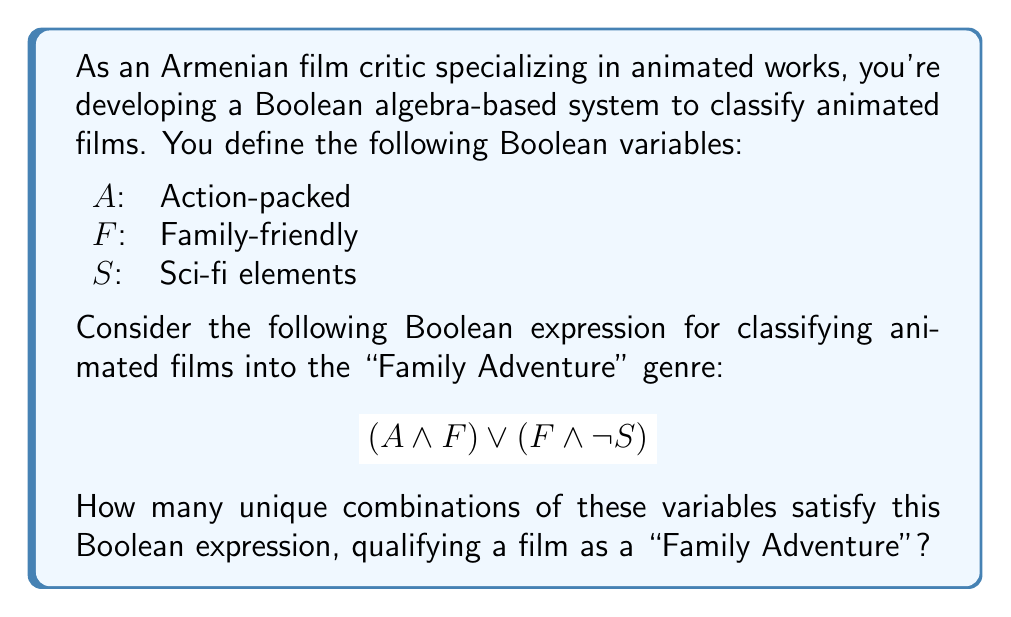Can you answer this question? Let's approach this step-by-step using a truth table:

1) First, we list all possible combinations of $A$, $F$, and $S$:

   $A$ | $F$ | $S$ | $(A \land F)$ | $(F \land \neg S)$ | Result
   ----+-----+-----+---------------+--------------------+-------
   0   | 0   | 0   |      0        |         0          |   0
   0   | 0   | 1   |      0        |         0          |   0
   0   | 1   | 0   |      0        |         1          |   1
   0   | 1   | 1   |      0        |         0          |   0
   1   | 0   | 0   |      0        |         0          |   0
   1   | 0   | 1   |      0        |         0          |   0
   1   | 1   | 0   |      1        |         1          |   1
   1   | 1   | 1   |      1        |         0          |   1

2) We evaluate $(A \land F)$ and $(F \land \neg S)$ for each combination.

3) The final result is the OR (∨) of these two expressions.

4) Counting the number of 1's in the Result column gives us the number of combinations that satisfy the expression.

We can see that there are three combinations that result in a 1:
- $A = 0$, $F = 1$, $S = 0$
- $A = 1$, $F = 1$, $S = 0$
- $A = 1$, $F = 1$, $S = 1$

Therefore, there are 3 unique combinations that satisfy this Boolean expression.
Answer: 3 